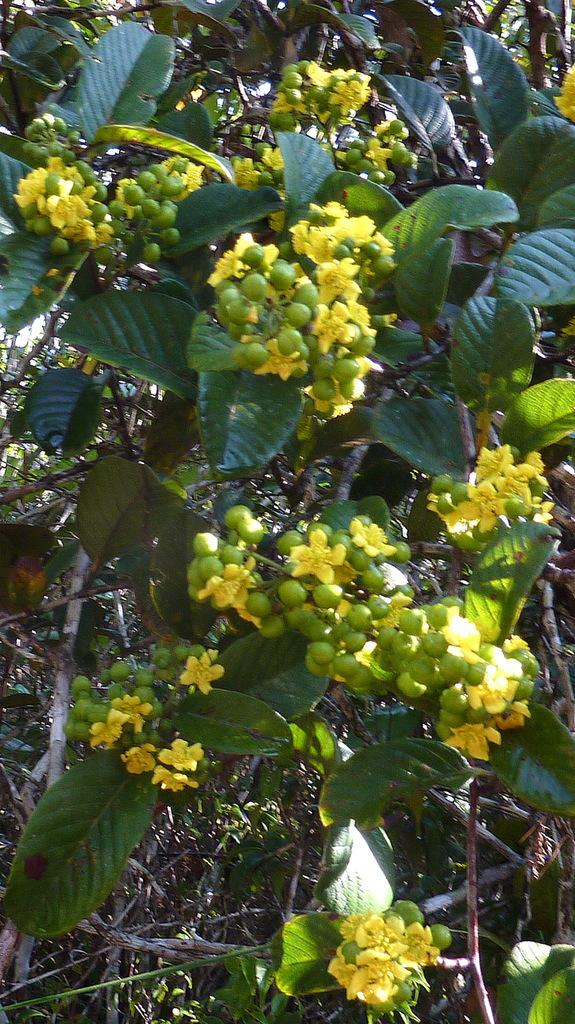What is located in the center of the image? There are plants and trees in the center of the image. What can be seen in the foreground of the image? There are fruits and flowers in the foreground of the image. What type of roof can be seen on the trees in the image? There are no roofs present on the trees in the image, as trees do not have roofs. 